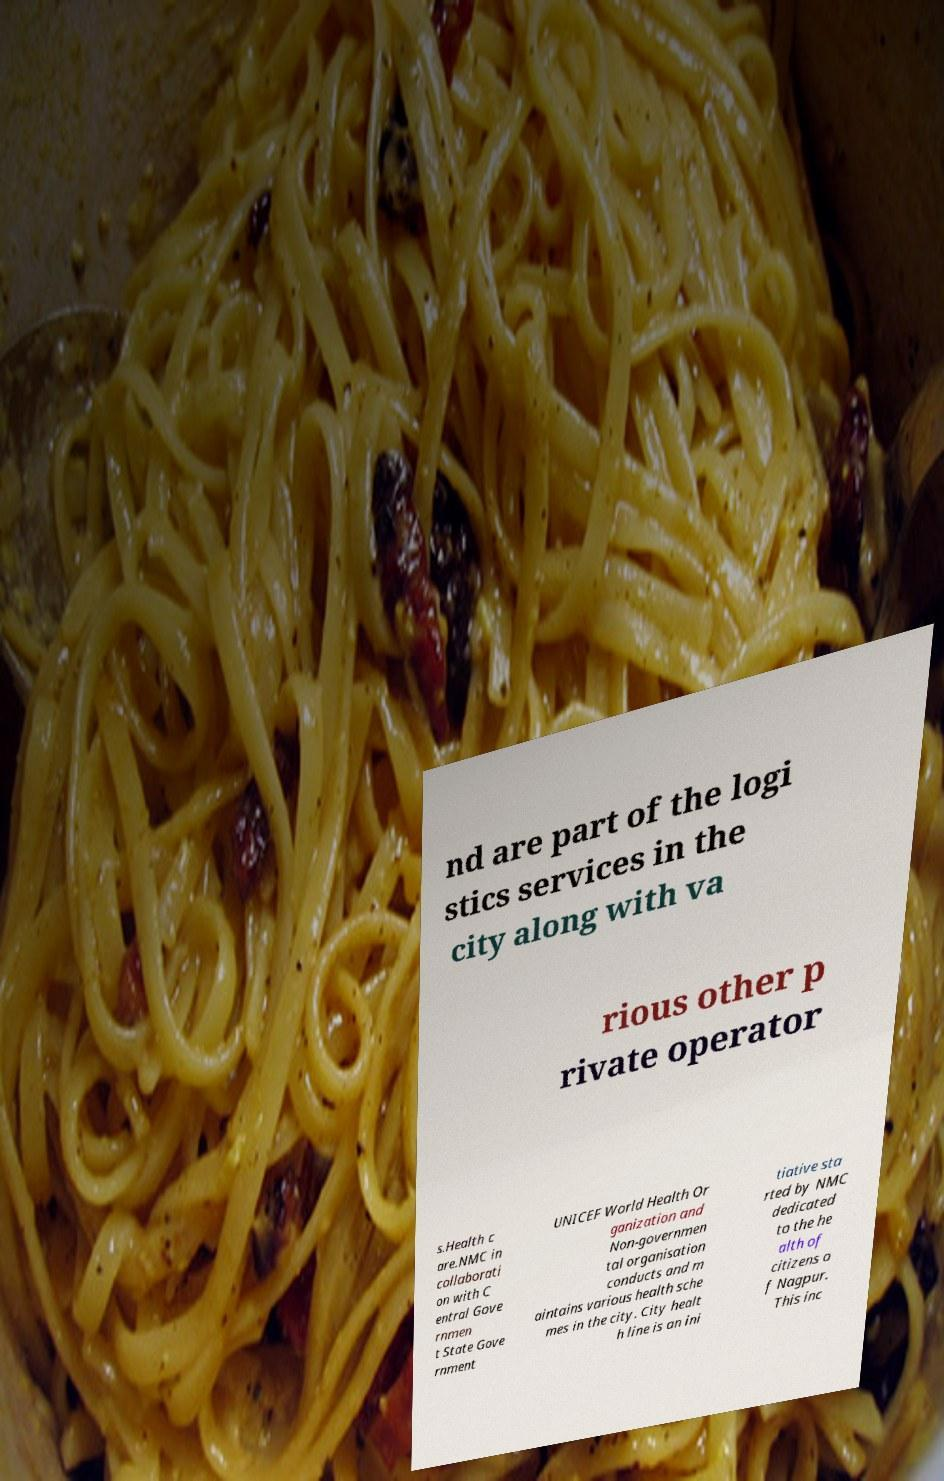What messages or text are displayed in this image? I need them in a readable, typed format. nd are part of the logi stics services in the city along with va rious other p rivate operator s.Health c are.NMC in collaborati on with C entral Gove rnmen t State Gove rnment UNICEF World Health Or ganization and Non-governmen tal organisation conducts and m aintains various health sche mes in the city. City healt h line is an ini tiative sta rted by NMC dedicated to the he alth of citizens o f Nagpur. This inc 